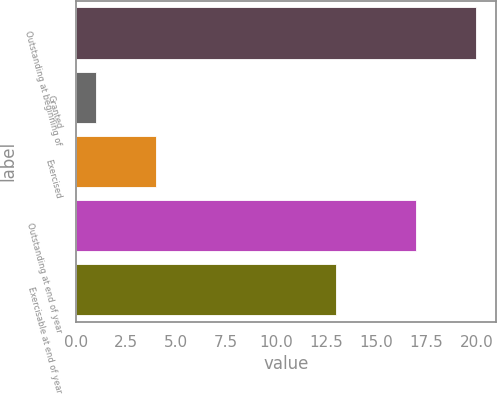Convert chart to OTSL. <chart><loc_0><loc_0><loc_500><loc_500><bar_chart><fcel>Outstanding at beginning of<fcel>Granted<fcel>Exercised<fcel>Outstanding at end of year<fcel>Exercisable at end of year<nl><fcel>20<fcel>1<fcel>4<fcel>17<fcel>13<nl></chart> 